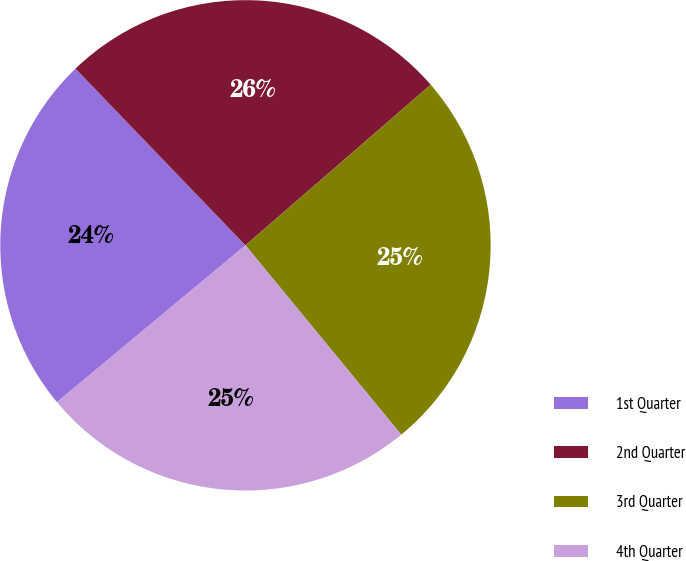<chart> <loc_0><loc_0><loc_500><loc_500><pie_chart><fcel>1st Quarter<fcel>2nd Quarter<fcel>3rd Quarter<fcel>4th Quarter<nl><fcel>23.85%<fcel>25.82%<fcel>25.41%<fcel>24.91%<nl></chart> 